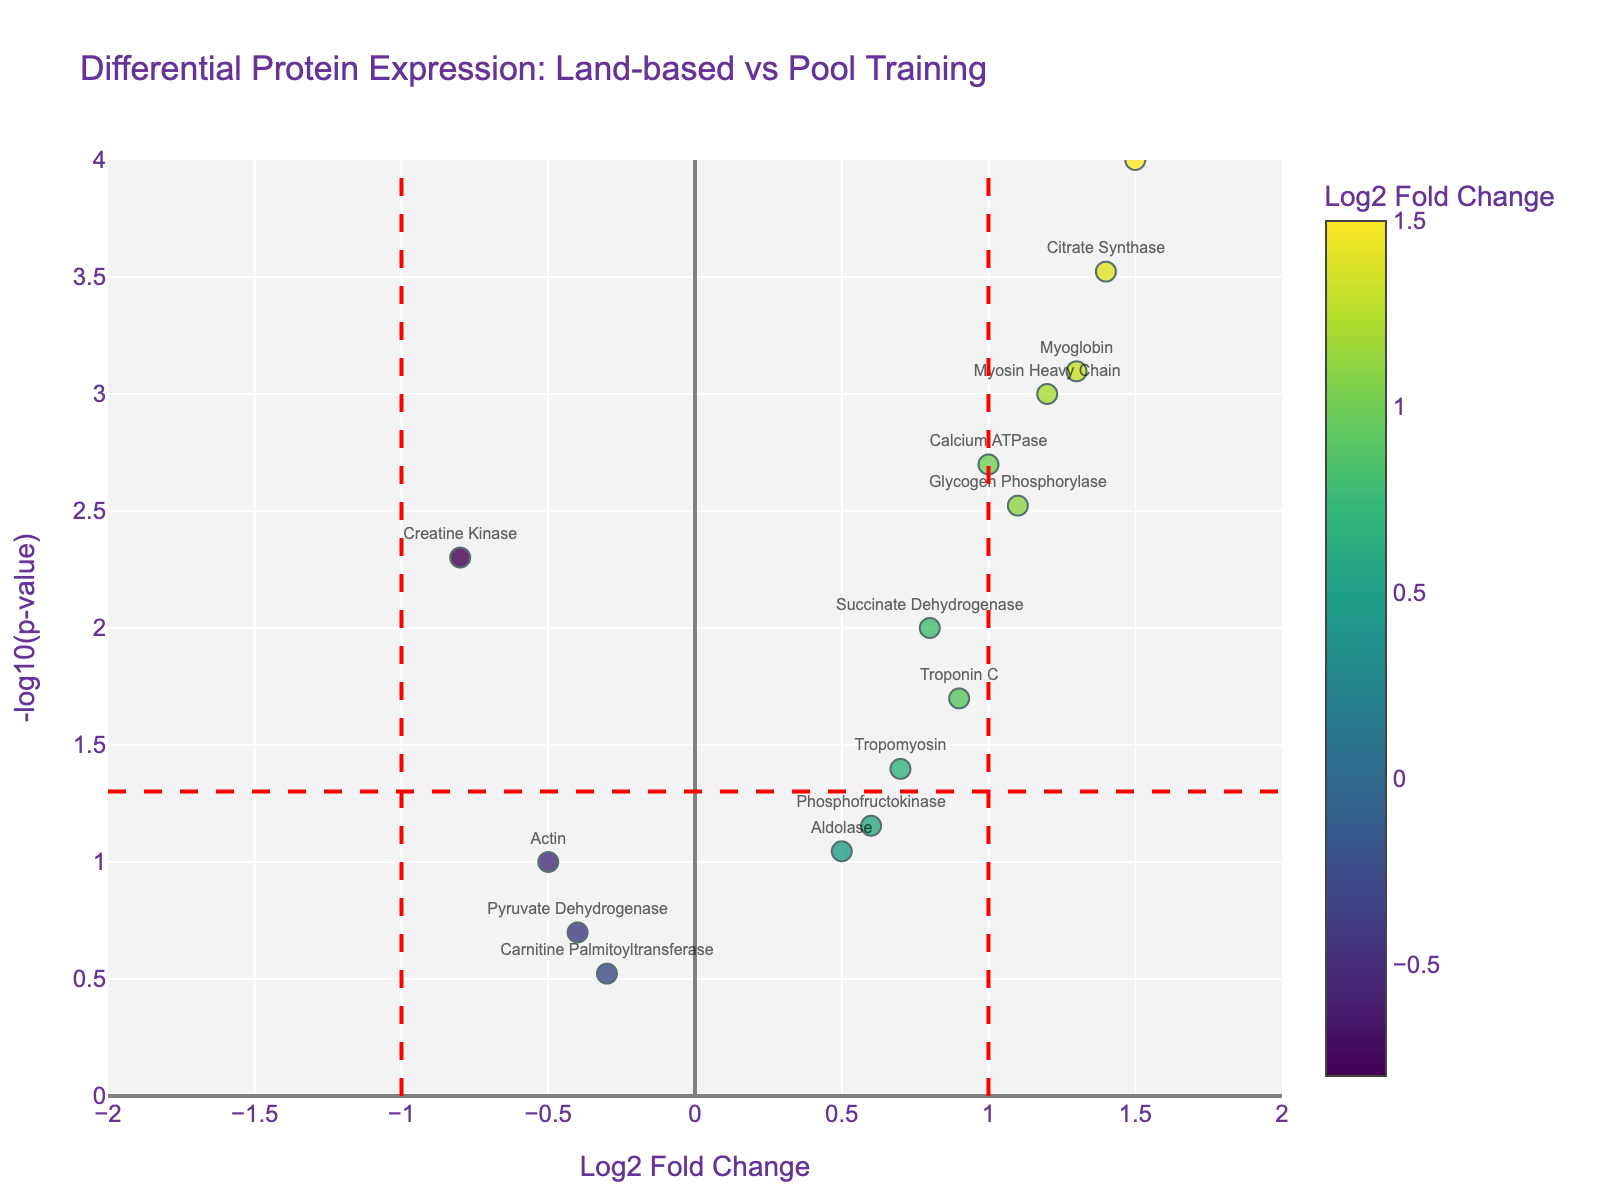What is the title of the figure? The title is usually displayed at the top center of the plot and summarizes the main theme of the plot. Here, the main theme is the differential protein expression in swimmer’s muscles after different training regimens.
Answer: Differential Protein Expression: Land-based vs Pool Training Which protein has the highest log2 fold change? Look at the x-axis (Log2 Fold Change) and identify the data point that is farthest to the right. This indicates the highest positive fold change.
Answer: Lactate Dehydrogenase What does the y-axis represent? The y-axis label can be found along the left side of the plot, indicating what the vertical dimension measures. In this plot, it measures the significance of the data points as -log10(p-value).
Answer: -log10(p-value) Which protein has the most significant p-value? The most significant p-value corresponds to the highest value on the y-axis. Look for the highest point on the plot.
Answer: Lactate Dehydrogenase How many data points show significant differential expression with a log2 fold change greater than 1? Significant differential expression typically means a p-value below 0.05 (-log10(p-value) > 1.3). Count the data points on the right side of the line at 1 on the x-axis and above the red horizontal line.
Answer: Four Which protein shows a decrease in expression after land-based strength training? Proteins with decreased expression will have negative Log2 Fold Change values (points on the left side of the plot). Identify such proteins below the horizontal red line for significance.
Answer: Creatine Kinase What is the log2 fold change for Myosin Heavy Chain? Look for the data point labeled ‘Myosin Heavy Chain’ and note its position along the x-axis.
Answer: 1.2 Which proteins have a p-value below 0.01? Proteins with a p-value below 0.01 will be situated above 2 on the y-axis (-log10(0.01) = 2). Identify the labels above this threshold.
Answer: Myosin Heavy Chain, Lactate Dehydrogenase, Glycogen Phosphorylase, Myoglobin, Calcium ATPase, Citrate Synthase What is the color representation used for? The legend or color bar in the plot indicates what the colors represent. Here, it is used to represent the log2 fold change values.
Answer: Log2 Fold Change Which proteins have a log2 fold change between -0.5 and 0.5? Locate the data points that fall within the range [-0.5, 0.5] on the x-axis. Ignore their position on the y-axis, but check these data points for any with relevant fold changes.
Answer: Actin, Pyruvate Dehydrogenase, Carnitine Palmitoyltransferase, Aldolase 